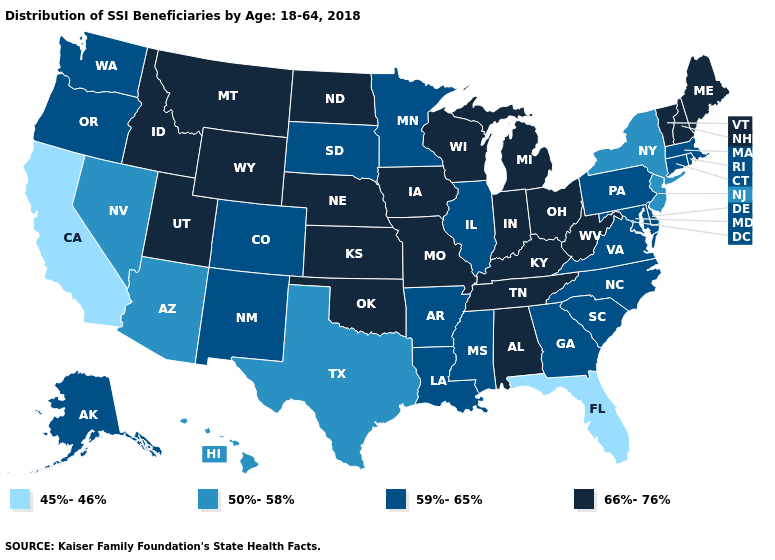What is the value of Maine?
Concise answer only. 66%-76%. What is the value of Iowa?
Quick response, please. 66%-76%. What is the lowest value in states that border New Jersey?
Concise answer only. 50%-58%. Name the states that have a value in the range 45%-46%?
Write a very short answer. California, Florida. What is the value of Arizona?
Answer briefly. 50%-58%. Among the states that border Colorado , does Kansas have the highest value?
Keep it brief. Yes. Does the map have missing data?
Give a very brief answer. No. Name the states that have a value in the range 45%-46%?
Concise answer only. California, Florida. What is the value of Oklahoma?
Write a very short answer. 66%-76%. What is the value of West Virginia?
Answer briefly. 66%-76%. Does Indiana have the same value as Montana?
Give a very brief answer. Yes. What is the lowest value in states that border Kansas?
Quick response, please. 59%-65%. Name the states that have a value in the range 59%-65%?
Write a very short answer. Alaska, Arkansas, Colorado, Connecticut, Delaware, Georgia, Illinois, Louisiana, Maryland, Massachusetts, Minnesota, Mississippi, New Mexico, North Carolina, Oregon, Pennsylvania, Rhode Island, South Carolina, South Dakota, Virginia, Washington. What is the value of Connecticut?
Short answer required. 59%-65%. What is the value of West Virginia?
Concise answer only. 66%-76%. 